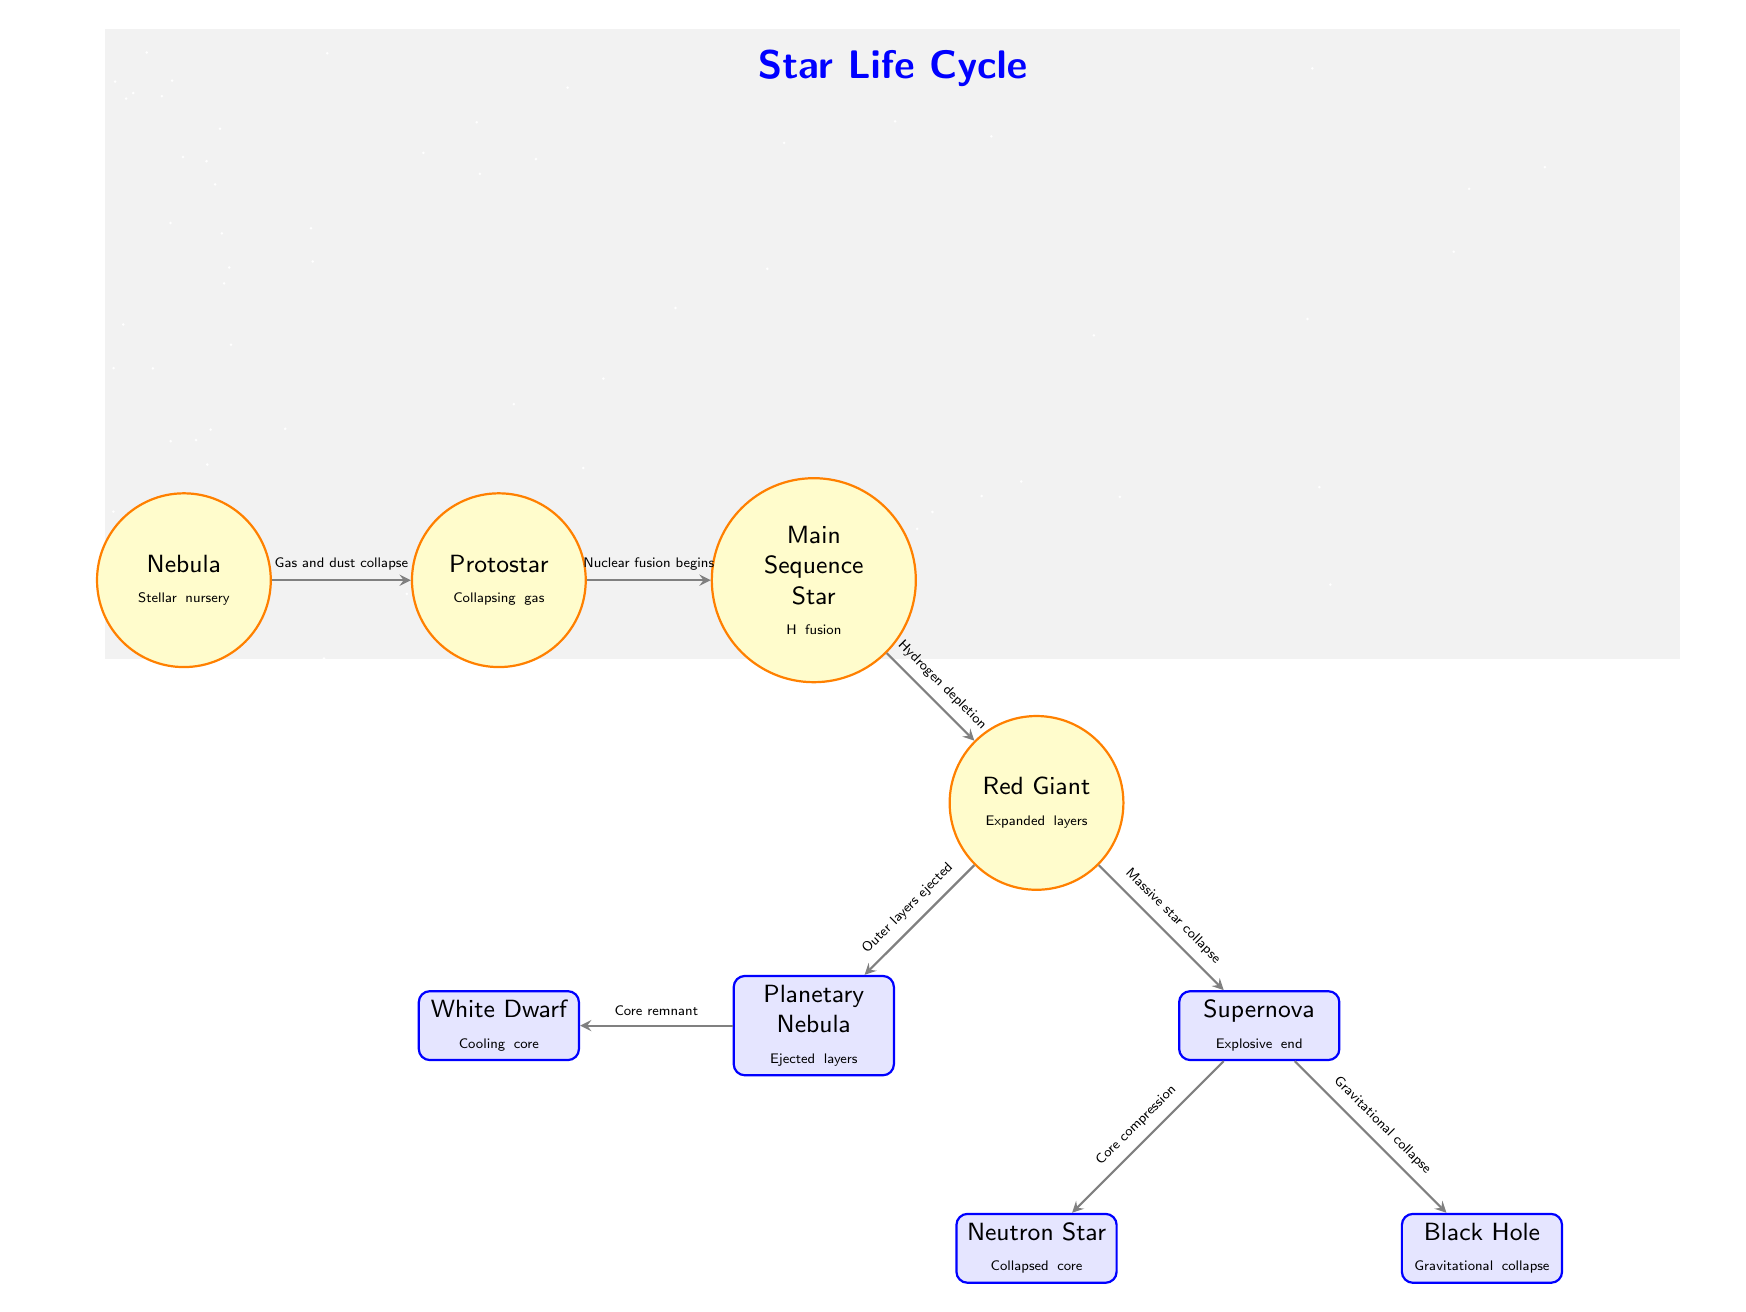What is the first stage of a star's life cycle? The first stage, as indicated in the diagram, is the Nebula which is labeled as "Stellar nursery."
Answer: Nebula What processes lead to the formation of a Protostar? The arrow labeled "Gas and dust collapse" originates from the Nebula and points to the Protostar, indicating that this process is responsible for its formation.
Answer: Gas and dust collapse How does a star transition from the Main Sequence to a Red Giant? The transition from Main Sequence to Red Giant is marked by the arrow labeled "Hydrogen depletion" that connects the two nodes, indicating that depletion of hydrogen fuels this transition.
Answer: Hydrogen depletion What are the two possible end states for a massive star after a Supernova? According to the diagram, the two end states are represented by the Neutron Star and Black Hole nodes, which are both connected to the Supernova.
Answer: Neutron Star and Black Hole What is ejected in the stage leading to the formation of a White Dwarf? The connection from the Red Giant to the Planetary Nebula, indicated by the arrow labeled "Outer layers ejected," signifies that the outer layers are ejected during this process.
Answer: Outer layers After Supernova occurs, what happens to the core? The arrows indicate two pathways from the Supernova: one leading to a Neutron Star through "Core compression" and the other to a Black Hole through "Gravitational collapse," both representing core events.
Answer: Core compression and Gravitational collapse How many distinct stages are represented in the diagram? By counting the nodes in the diagram, we identify a total of eight distinct stages, including both stars and their end states.
Answer: Eight Which stage involves the beginning of nuclear fusion? The diagram indicates that nuclear fusion begins at the Protostar stage, as shown by the arrow labeled "Nuclear fusion begins" leading to the Main Sequence Star.
Answer: Protostar What connects the Red Giant to the Planetary Nebula? The arrow labeled "Outer layers ejected" connects the Red Giant to the Planetary Nebula, indicating the mechanism through which this connection occurs.
Answer: Outer layers ejected 